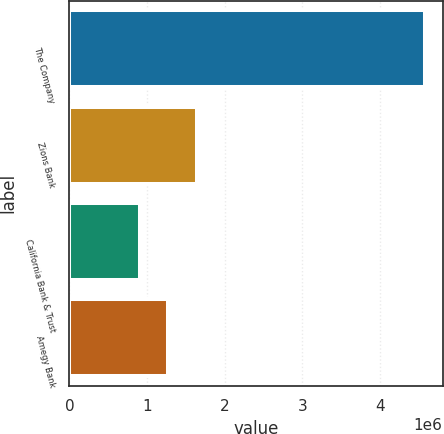Convert chart. <chart><loc_0><loc_0><loc_500><loc_500><bar_chart><fcel>The Company<fcel>Zions Bank<fcel>California Bank & Trust<fcel>Amegy Bank<nl><fcel>4.57377e+06<fcel>1.64029e+06<fcel>906915<fcel>1.2736e+06<nl></chart> 